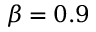Convert formula to latex. <formula><loc_0><loc_0><loc_500><loc_500>\beta = 0 . 9</formula> 